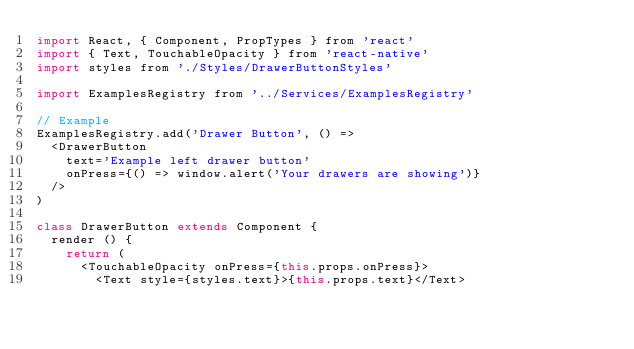<code> <loc_0><loc_0><loc_500><loc_500><_JavaScript_>import React, { Component, PropTypes } from 'react'
import { Text, TouchableOpacity } from 'react-native'
import styles from './Styles/DrawerButtonStyles'

import ExamplesRegistry from '../Services/ExamplesRegistry'

// Example
ExamplesRegistry.add('Drawer Button', () =>
  <DrawerButton
    text='Example left drawer button'
    onPress={() => window.alert('Your drawers are showing')}
  />
)

class DrawerButton extends Component {
  render () {
    return (
      <TouchableOpacity onPress={this.props.onPress}>
        <Text style={styles.text}>{this.props.text}</Text></code> 